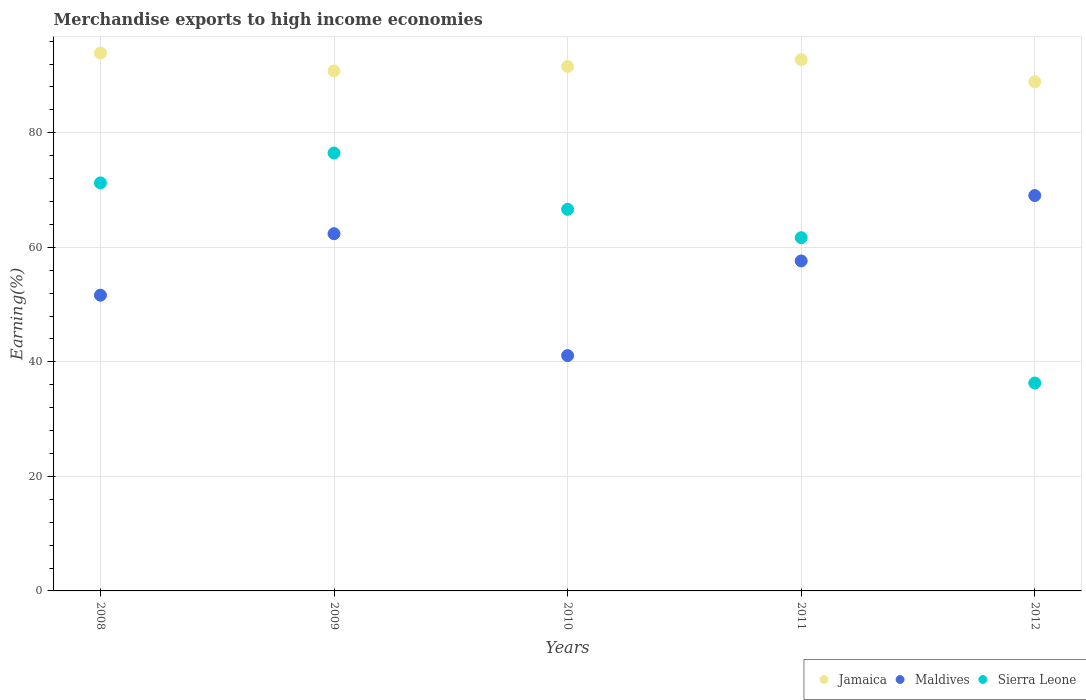What is the percentage of amount earned from merchandise exports in Jamaica in 2008?
Keep it short and to the point. 93.92. Across all years, what is the maximum percentage of amount earned from merchandise exports in Maldives?
Offer a terse response. 69.04. Across all years, what is the minimum percentage of amount earned from merchandise exports in Jamaica?
Provide a succinct answer. 88.92. What is the total percentage of amount earned from merchandise exports in Jamaica in the graph?
Provide a succinct answer. 457.98. What is the difference between the percentage of amount earned from merchandise exports in Sierra Leone in 2010 and that in 2012?
Your response must be concise. 30.34. What is the difference between the percentage of amount earned from merchandise exports in Maldives in 2011 and the percentage of amount earned from merchandise exports in Sierra Leone in 2012?
Keep it short and to the point. 21.32. What is the average percentage of amount earned from merchandise exports in Jamaica per year?
Offer a very short reply. 91.6. In the year 2012, what is the difference between the percentage of amount earned from merchandise exports in Jamaica and percentage of amount earned from merchandise exports in Sierra Leone?
Offer a very short reply. 52.62. In how many years, is the percentage of amount earned from merchandise exports in Sierra Leone greater than 76 %?
Provide a succinct answer. 1. What is the ratio of the percentage of amount earned from merchandise exports in Jamaica in 2009 to that in 2012?
Your answer should be compact. 1.02. What is the difference between the highest and the second highest percentage of amount earned from merchandise exports in Sierra Leone?
Keep it short and to the point. 5.22. What is the difference between the highest and the lowest percentage of amount earned from merchandise exports in Sierra Leone?
Your answer should be compact. 40.17. Is the sum of the percentage of amount earned from merchandise exports in Maldives in 2008 and 2009 greater than the maximum percentage of amount earned from merchandise exports in Sierra Leone across all years?
Offer a very short reply. Yes. Is it the case that in every year, the sum of the percentage of amount earned from merchandise exports in Maldives and percentage of amount earned from merchandise exports in Jamaica  is greater than the percentage of amount earned from merchandise exports in Sierra Leone?
Make the answer very short. Yes. Is the percentage of amount earned from merchandise exports in Maldives strictly greater than the percentage of amount earned from merchandise exports in Jamaica over the years?
Your answer should be compact. No. Is the percentage of amount earned from merchandise exports in Maldives strictly less than the percentage of amount earned from merchandise exports in Jamaica over the years?
Make the answer very short. Yes. How many years are there in the graph?
Your answer should be compact. 5. What is the difference between two consecutive major ticks on the Y-axis?
Your response must be concise. 20. Are the values on the major ticks of Y-axis written in scientific E-notation?
Your answer should be very brief. No. How many legend labels are there?
Your response must be concise. 3. How are the legend labels stacked?
Offer a very short reply. Horizontal. What is the title of the graph?
Keep it short and to the point. Merchandise exports to high income economies. Does "Kiribati" appear as one of the legend labels in the graph?
Keep it short and to the point. No. What is the label or title of the Y-axis?
Keep it short and to the point. Earning(%). What is the Earning(%) of Jamaica in 2008?
Give a very brief answer. 93.92. What is the Earning(%) in Maldives in 2008?
Your answer should be compact. 51.64. What is the Earning(%) of Sierra Leone in 2008?
Your answer should be compact. 71.25. What is the Earning(%) in Jamaica in 2009?
Provide a short and direct response. 90.79. What is the Earning(%) in Maldives in 2009?
Your response must be concise. 62.38. What is the Earning(%) of Sierra Leone in 2009?
Your answer should be compact. 76.47. What is the Earning(%) of Jamaica in 2010?
Keep it short and to the point. 91.58. What is the Earning(%) of Maldives in 2010?
Provide a succinct answer. 41.09. What is the Earning(%) of Sierra Leone in 2010?
Keep it short and to the point. 66.64. What is the Earning(%) of Jamaica in 2011?
Provide a succinct answer. 92.77. What is the Earning(%) of Maldives in 2011?
Keep it short and to the point. 57.62. What is the Earning(%) in Sierra Leone in 2011?
Provide a succinct answer. 61.68. What is the Earning(%) in Jamaica in 2012?
Your answer should be very brief. 88.92. What is the Earning(%) of Maldives in 2012?
Your answer should be very brief. 69.04. What is the Earning(%) of Sierra Leone in 2012?
Your response must be concise. 36.3. Across all years, what is the maximum Earning(%) of Jamaica?
Make the answer very short. 93.92. Across all years, what is the maximum Earning(%) in Maldives?
Your answer should be compact. 69.04. Across all years, what is the maximum Earning(%) in Sierra Leone?
Ensure brevity in your answer.  76.47. Across all years, what is the minimum Earning(%) in Jamaica?
Your answer should be very brief. 88.92. Across all years, what is the minimum Earning(%) in Maldives?
Offer a terse response. 41.09. Across all years, what is the minimum Earning(%) of Sierra Leone?
Offer a terse response. 36.3. What is the total Earning(%) in Jamaica in the graph?
Provide a succinct answer. 457.98. What is the total Earning(%) of Maldives in the graph?
Keep it short and to the point. 281.78. What is the total Earning(%) of Sierra Leone in the graph?
Make the answer very short. 312.33. What is the difference between the Earning(%) of Jamaica in 2008 and that in 2009?
Your answer should be very brief. 3.13. What is the difference between the Earning(%) of Maldives in 2008 and that in 2009?
Ensure brevity in your answer.  -10.74. What is the difference between the Earning(%) in Sierra Leone in 2008 and that in 2009?
Your answer should be very brief. -5.22. What is the difference between the Earning(%) in Jamaica in 2008 and that in 2010?
Offer a very short reply. 2.34. What is the difference between the Earning(%) in Maldives in 2008 and that in 2010?
Provide a succinct answer. 10.55. What is the difference between the Earning(%) of Sierra Leone in 2008 and that in 2010?
Your response must be concise. 4.61. What is the difference between the Earning(%) of Jamaica in 2008 and that in 2011?
Your response must be concise. 1.15. What is the difference between the Earning(%) of Maldives in 2008 and that in 2011?
Your response must be concise. -5.98. What is the difference between the Earning(%) in Sierra Leone in 2008 and that in 2011?
Your answer should be compact. 9.56. What is the difference between the Earning(%) of Jamaica in 2008 and that in 2012?
Your answer should be very brief. 5. What is the difference between the Earning(%) of Maldives in 2008 and that in 2012?
Provide a short and direct response. -17.4. What is the difference between the Earning(%) of Sierra Leone in 2008 and that in 2012?
Keep it short and to the point. 34.95. What is the difference between the Earning(%) of Jamaica in 2009 and that in 2010?
Keep it short and to the point. -0.79. What is the difference between the Earning(%) in Maldives in 2009 and that in 2010?
Provide a succinct answer. 21.29. What is the difference between the Earning(%) of Sierra Leone in 2009 and that in 2010?
Give a very brief answer. 9.83. What is the difference between the Earning(%) of Jamaica in 2009 and that in 2011?
Offer a very short reply. -1.98. What is the difference between the Earning(%) in Maldives in 2009 and that in 2011?
Ensure brevity in your answer.  4.76. What is the difference between the Earning(%) in Sierra Leone in 2009 and that in 2011?
Provide a succinct answer. 14.79. What is the difference between the Earning(%) in Jamaica in 2009 and that in 2012?
Provide a short and direct response. 1.87. What is the difference between the Earning(%) in Maldives in 2009 and that in 2012?
Offer a terse response. -6.66. What is the difference between the Earning(%) in Sierra Leone in 2009 and that in 2012?
Provide a succinct answer. 40.17. What is the difference between the Earning(%) in Jamaica in 2010 and that in 2011?
Your answer should be compact. -1.2. What is the difference between the Earning(%) of Maldives in 2010 and that in 2011?
Make the answer very short. -16.53. What is the difference between the Earning(%) in Sierra Leone in 2010 and that in 2011?
Offer a very short reply. 4.96. What is the difference between the Earning(%) in Jamaica in 2010 and that in 2012?
Keep it short and to the point. 2.65. What is the difference between the Earning(%) in Maldives in 2010 and that in 2012?
Your answer should be compact. -27.95. What is the difference between the Earning(%) in Sierra Leone in 2010 and that in 2012?
Provide a succinct answer. 30.34. What is the difference between the Earning(%) of Jamaica in 2011 and that in 2012?
Offer a very short reply. 3.85. What is the difference between the Earning(%) in Maldives in 2011 and that in 2012?
Your answer should be compact. -11.42. What is the difference between the Earning(%) in Sierra Leone in 2011 and that in 2012?
Give a very brief answer. 25.38. What is the difference between the Earning(%) of Jamaica in 2008 and the Earning(%) of Maldives in 2009?
Ensure brevity in your answer.  31.54. What is the difference between the Earning(%) in Jamaica in 2008 and the Earning(%) in Sierra Leone in 2009?
Provide a short and direct response. 17.45. What is the difference between the Earning(%) in Maldives in 2008 and the Earning(%) in Sierra Leone in 2009?
Your response must be concise. -24.83. What is the difference between the Earning(%) in Jamaica in 2008 and the Earning(%) in Maldives in 2010?
Your response must be concise. 52.83. What is the difference between the Earning(%) of Jamaica in 2008 and the Earning(%) of Sierra Leone in 2010?
Give a very brief answer. 27.28. What is the difference between the Earning(%) of Maldives in 2008 and the Earning(%) of Sierra Leone in 2010?
Your response must be concise. -15. What is the difference between the Earning(%) in Jamaica in 2008 and the Earning(%) in Maldives in 2011?
Provide a short and direct response. 36.3. What is the difference between the Earning(%) in Jamaica in 2008 and the Earning(%) in Sierra Leone in 2011?
Your answer should be very brief. 32.24. What is the difference between the Earning(%) of Maldives in 2008 and the Earning(%) of Sierra Leone in 2011?
Make the answer very short. -10.04. What is the difference between the Earning(%) of Jamaica in 2008 and the Earning(%) of Maldives in 2012?
Your answer should be compact. 24.88. What is the difference between the Earning(%) in Jamaica in 2008 and the Earning(%) in Sierra Leone in 2012?
Make the answer very short. 57.62. What is the difference between the Earning(%) of Maldives in 2008 and the Earning(%) of Sierra Leone in 2012?
Offer a terse response. 15.34. What is the difference between the Earning(%) in Jamaica in 2009 and the Earning(%) in Maldives in 2010?
Provide a short and direct response. 49.7. What is the difference between the Earning(%) of Jamaica in 2009 and the Earning(%) of Sierra Leone in 2010?
Your answer should be compact. 24.15. What is the difference between the Earning(%) in Maldives in 2009 and the Earning(%) in Sierra Leone in 2010?
Your response must be concise. -4.26. What is the difference between the Earning(%) of Jamaica in 2009 and the Earning(%) of Maldives in 2011?
Your answer should be compact. 33.17. What is the difference between the Earning(%) of Jamaica in 2009 and the Earning(%) of Sierra Leone in 2011?
Ensure brevity in your answer.  29.11. What is the difference between the Earning(%) of Maldives in 2009 and the Earning(%) of Sierra Leone in 2011?
Your answer should be compact. 0.7. What is the difference between the Earning(%) in Jamaica in 2009 and the Earning(%) in Maldives in 2012?
Make the answer very short. 21.75. What is the difference between the Earning(%) in Jamaica in 2009 and the Earning(%) in Sierra Leone in 2012?
Offer a very short reply. 54.49. What is the difference between the Earning(%) of Maldives in 2009 and the Earning(%) of Sierra Leone in 2012?
Offer a terse response. 26.08. What is the difference between the Earning(%) of Jamaica in 2010 and the Earning(%) of Maldives in 2011?
Offer a terse response. 33.95. What is the difference between the Earning(%) of Jamaica in 2010 and the Earning(%) of Sierra Leone in 2011?
Provide a short and direct response. 29.89. What is the difference between the Earning(%) of Maldives in 2010 and the Earning(%) of Sierra Leone in 2011?
Offer a very short reply. -20.59. What is the difference between the Earning(%) of Jamaica in 2010 and the Earning(%) of Maldives in 2012?
Your answer should be very brief. 22.53. What is the difference between the Earning(%) of Jamaica in 2010 and the Earning(%) of Sierra Leone in 2012?
Keep it short and to the point. 55.28. What is the difference between the Earning(%) of Maldives in 2010 and the Earning(%) of Sierra Leone in 2012?
Ensure brevity in your answer.  4.79. What is the difference between the Earning(%) of Jamaica in 2011 and the Earning(%) of Maldives in 2012?
Your answer should be compact. 23.73. What is the difference between the Earning(%) of Jamaica in 2011 and the Earning(%) of Sierra Leone in 2012?
Your response must be concise. 56.47. What is the difference between the Earning(%) of Maldives in 2011 and the Earning(%) of Sierra Leone in 2012?
Your response must be concise. 21.32. What is the average Earning(%) of Jamaica per year?
Provide a succinct answer. 91.6. What is the average Earning(%) of Maldives per year?
Your answer should be very brief. 56.36. What is the average Earning(%) in Sierra Leone per year?
Provide a succinct answer. 62.47. In the year 2008, what is the difference between the Earning(%) of Jamaica and Earning(%) of Maldives?
Your answer should be very brief. 42.28. In the year 2008, what is the difference between the Earning(%) in Jamaica and Earning(%) in Sierra Leone?
Offer a terse response. 22.67. In the year 2008, what is the difference between the Earning(%) of Maldives and Earning(%) of Sierra Leone?
Keep it short and to the point. -19.6. In the year 2009, what is the difference between the Earning(%) of Jamaica and Earning(%) of Maldives?
Your response must be concise. 28.41. In the year 2009, what is the difference between the Earning(%) of Jamaica and Earning(%) of Sierra Leone?
Provide a succinct answer. 14.32. In the year 2009, what is the difference between the Earning(%) in Maldives and Earning(%) in Sierra Leone?
Your answer should be very brief. -14.09. In the year 2010, what is the difference between the Earning(%) of Jamaica and Earning(%) of Maldives?
Your answer should be very brief. 50.48. In the year 2010, what is the difference between the Earning(%) of Jamaica and Earning(%) of Sierra Leone?
Ensure brevity in your answer.  24.94. In the year 2010, what is the difference between the Earning(%) in Maldives and Earning(%) in Sierra Leone?
Your answer should be very brief. -25.55. In the year 2011, what is the difference between the Earning(%) of Jamaica and Earning(%) of Maldives?
Keep it short and to the point. 35.15. In the year 2011, what is the difference between the Earning(%) in Jamaica and Earning(%) in Sierra Leone?
Ensure brevity in your answer.  31.09. In the year 2011, what is the difference between the Earning(%) in Maldives and Earning(%) in Sierra Leone?
Offer a terse response. -4.06. In the year 2012, what is the difference between the Earning(%) in Jamaica and Earning(%) in Maldives?
Offer a very short reply. 19.88. In the year 2012, what is the difference between the Earning(%) of Jamaica and Earning(%) of Sierra Leone?
Ensure brevity in your answer.  52.62. In the year 2012, what is the difference between the Earning(%) in Maldives and Earning(%) in Sierra Leone?
Provide a succinct answer. 32.74. What is the ratio of the Earning(%) of Jamaica in 2008 to that in 2009?
Your answer should be compact. 1.03. What is the ratio of the Earning(%) of Maldives in 2008 to that in 2009?
Give a very brief answer. 0.83. What is the ratio of the Earning(%) of Sierra Leone in 2008 to that in 2009?
Offer a terse response. 0.93. What is the ratio of the Earning(%) of Jamaica in 2008 to that in 2010?
Your answer should be very brief. 1.03. What is the ratio of the Earning(%) in Maldives in 2008 to that in 2010?
Give a very brief answer. 1.26. What is the ratio of the Earning(%) of Sierra Leone in 2008 to that in 2010?
Your response must be concise. 1.07. What is the ratio of the Earning(%) in Jamaica in 2008 to that in 2011?
Keep it short and to the point. 1.01. What is the ratio of the Earning(%) in Maldives in 2008 to that in 2011?
Give a very brief answer. 0.9. What is the ratio of the Earning(%) of Sierra Leone in 2008 to that in 2011?
Keep it short and to the point. 1.16. What is the ratio of the Earning(%) in Jamaica in 2008 to that in 2012?
Provide a succinct answer. 1.06. What is the ratio of the Earning(%) in Maldives in 2008 to that in 2012?
Give a very brief answer. 0.75. What is the ratio of the Earning(%) in Sierra Leone in 2008 to that in 2012?
Your response must be concise. 1.96. What is the ratio of the Earning(%) in Jamaica in 2009 to that in 2010?
Your response must be concise. 0.99. What is the ratio of the Earning(%) of Maldives in 2009 to that in 2010?
Ensure brevity in your answer.  1.52. What is the ratio of the Earning(%) in Sierra Leone in 2009 to that in 2010?
Your answer should be very brief. 1.15. What is the ratio of the Earning(%) of Jamaica in 2009 to that in 2011?
Keep it short and to the point. 0.98. What is the ratio of the Earning(%) in Maldives in 2009 to that in 2011?
Your answer should be very brief. 1.08. What is the ratio of the Earning(%) of Sierra Leone in 2009 to that in 2011?
Your answer should be very brief. 1.24. What is the ratio of the Earning(%) of Maldives in 2009 to that in 2012?
Give a very brief answer. 0.9. What is the ratio of the Earning(%) of Sierra Leone in 2009 to that in 2012?
Provide a succinct answer. 2.11. What is the ratio of the Earning(%) of Jamaica in 2010 to that in 2011?
Provide a succinct answer. 0.99. What is the ratio of the Earning(%) in Maldives in 2010 to that in 2011?
Ensure brevity in your answer.  0.71. What is the ratio of the Earning(%) of Sierra Leone in 2010 to that in 2011?
Provide a short and direct response. 1.08. What is the ratio of the Earning(%) in Jamaica in 2010 to that in 2012?
Ensure brevity in your answer.  1.03. What is the ratio of the Earning(%) of Maldives in 2010 to that in 2012?
Provide a succinct answer. 0.6. What is the ratio of the Earning(%) of Sierra Leone in 2010 to that in 2012?
Provide a short and direct response. 1.84. What is the ratio of the Earning(%) in Jamaica in 2011 to that in 2012?
Make the answer very short. 1.04. What is the ratio of the Earning(%) in Maldives in 2011 to that in 2012?
Keep it short and to the point. 0.83. What is the ratio of the Earning(%) of Sierra Leone in 2011 to that in 2012?
Offer a very short reply. 1.7. What is the difference between the highest and the second highest Earning(%) of Jamaica?
Keep it short and to the point. 1.15. What is the difference between the highest and the second highest Earning(%) in Maldives?
Your response must be concise. 6.66. What is the difference between the highest and the second highest Earning(%) of Sierra Leone?
Offer a very short reply. 5.22. What is the difference between the highest and the lowest Earning(%) of Jamaica?
Offer a terse response. 5. What is the difference between the highest and the lowest Earning(%) in Maldives?
Ensure brevity in your answer.  27.95. What is the difference between the highest and the lowest Earning(%) in Sierra Leone?
Your response must be concise. 40.17. 